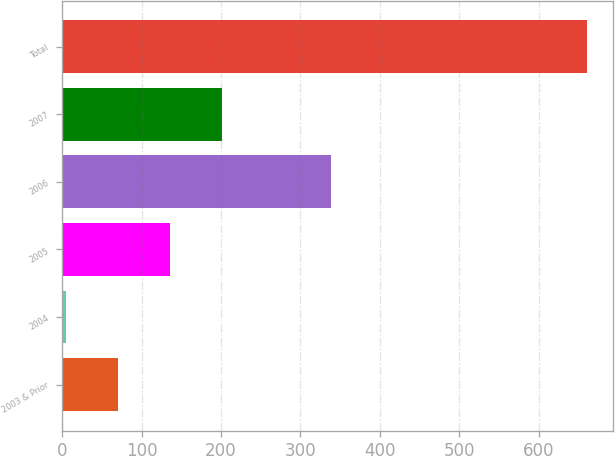Convert chart. <chart><loc_0><loc_0><loc_500><loc_500><bar_chart><fcel>2003 & Prior<fcel>2004<fcel>2005<fcel>2006<fcel>2007<fcel>Total<nl><fcel>70.5<fcel>5<fcel>136<fcel>339<fcel>201.5<fcel>660<nl></chart> 